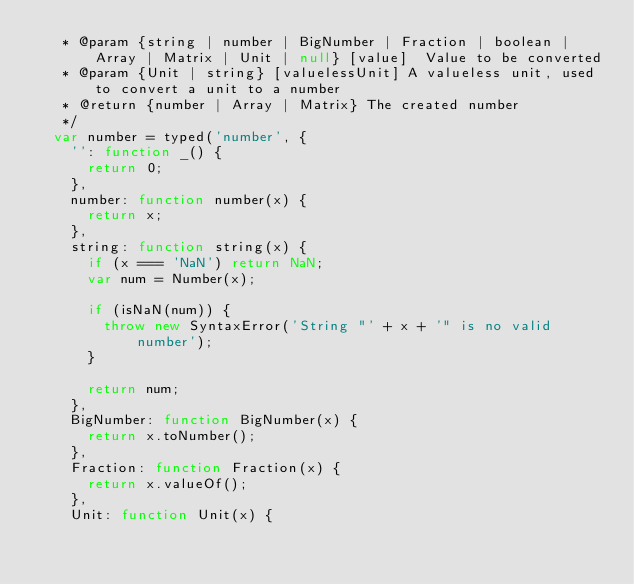Convert code to text. <code><loc_0><loc_0><loc_500><loc_500><_JavaScript_>   * @param {string | number | BigNumber | Fraction | boolean | Array | Matrix | Unit | null} [value]  Value to be converted
   * @param {Unit | string} [valuelessUnit] A valueless unit, used to convert a unit to a number
   * @return {number | Array | Matrix} The created number
   */
  var number = typed('number', {
    '': function _() {
      return 0;
    },
    number: function number(x) {
      return x;
    },
    string: function string(x) {
      if (x === 'NaN') return NaN;
      var num = Number(x);

      if (isNaN(num)) {
        throw new SyntaxError('String "' + x + '" is no valid number');
      }

      return num;
    },
    BigNumber: function BigNumber(x) {
      return x.toNumber();
    },
    Fraction: function Fraction(x) {
      return x.valueOf();
    },
    Unit: function Unit(x) {</code> 